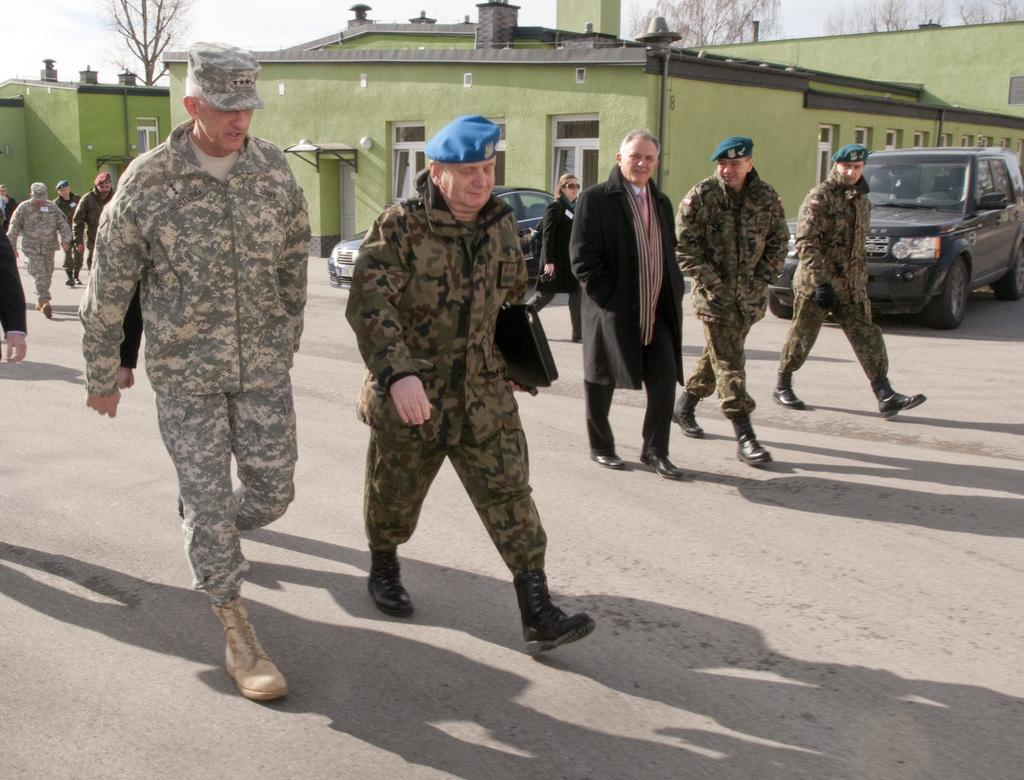How many military men are present in the image? There are five military men in the image. What are the military men wearing? The military men are wearing green dress. What are the military men doing in the image? The military men are walking on the road. What can be seen in the background of the image? There is a green color house and a black color Range Rover car parked in the background. What type of pan is being used to cook the soup in the image? There is no pan or soup present in the image; it features five military men walking on the road. How many mice can be seen running around the military men in the image? There are no mice present in the image. 